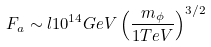Convert formula to latex. <formula><loc_0><loc_0><loc_500><loc_500>F _ { a } \sim l 1 0 ^ { 1 4 } G e V \left ( \frac { m _ { \phi } } { 1 T e V } \right ) ^ { 3 / 2 }</formula> 